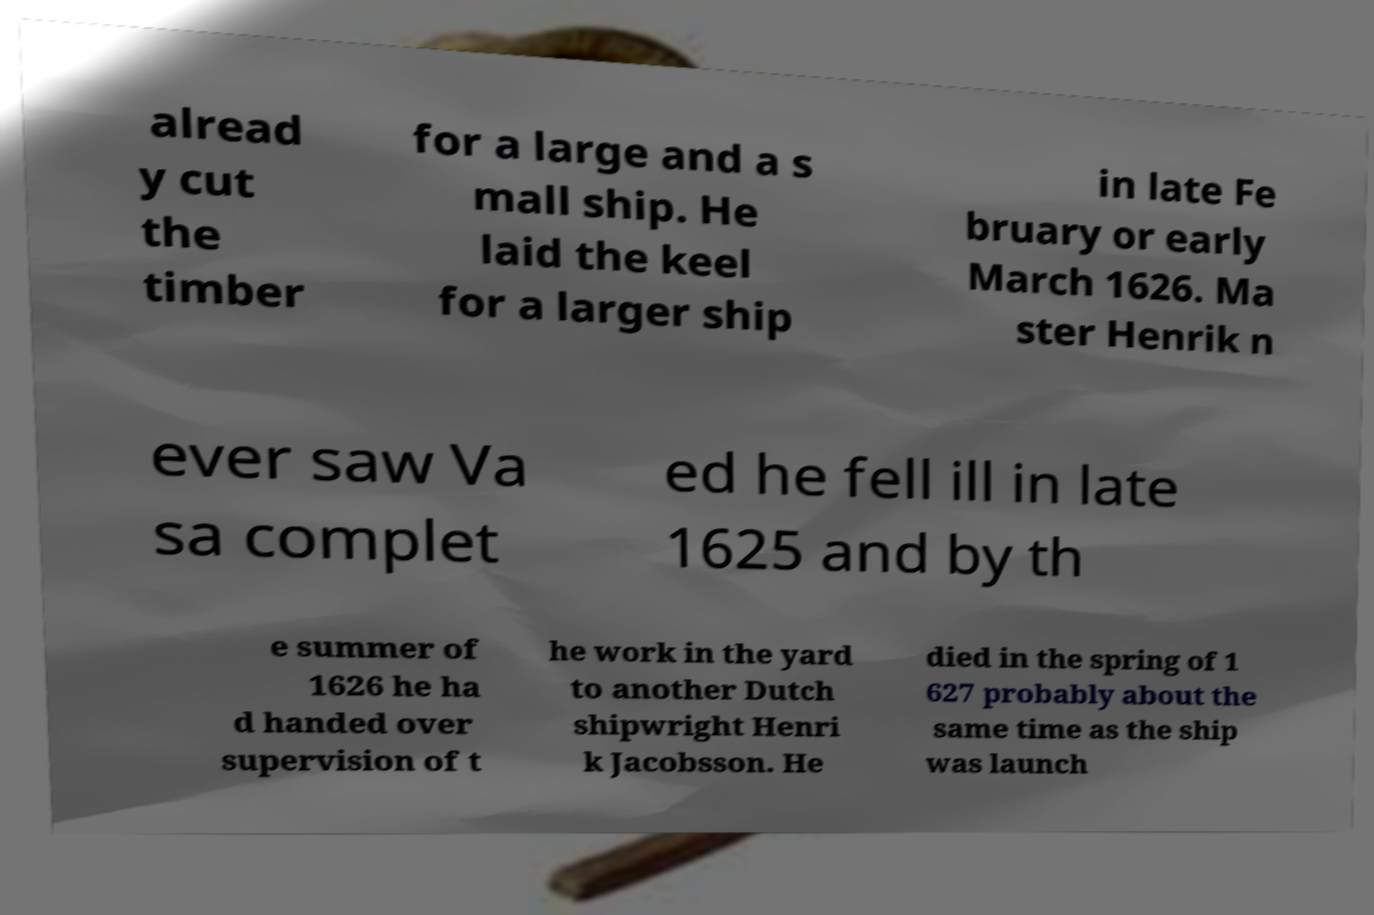Could you assist in decoding the text presented in this image and type it out clearly? alread y cut the timber for a large and a s mall ship. He laid the keel for a larger ship in late Fe bruary or early March 1626. Ma ster Henrik n ever saw Va sa complet ed he fell ill in late 1625 and by th e summer of 1626 he ha d handed over supervision of t he work in the yard to another Dutch shipwright Henri k Jacobsson. He died in the spring of 1 627 probably about the same time as the ship was launch 